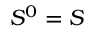<formula> <loc_0><loc_0><loc_500><loc_500>S ^ { 0 } = S</formula> 